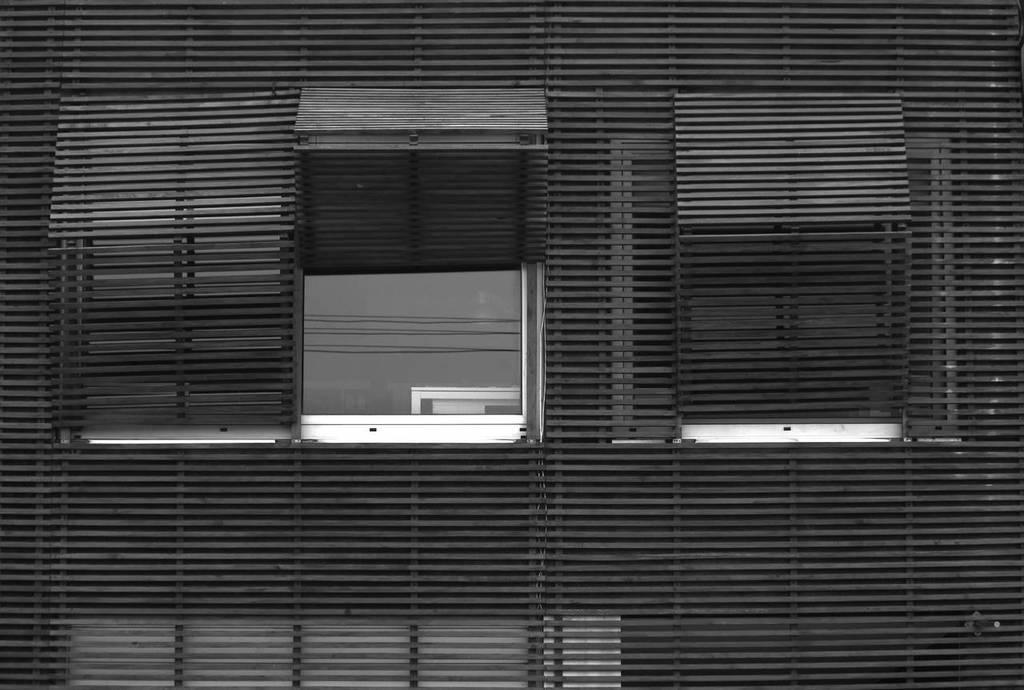Can you describe this image briefly? In this image there is a blind to a window, one of the blind is opened. 